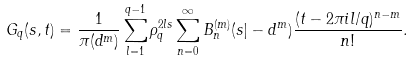<formula> <loc_0><loc_0><loc_500><loc_500>G _ { q } ( s , t ) = \frac { 1 } { \pi ( { d } ^ { m } ) } \sum _ { l = 1 } ^ { q - 1 } \rho _ { q } ^ { 2 l s } \sum _ { n = 0 } ^ { \infty } B _ { n } ^ { ( m ) } ( s | - { d } ^ { m } ) \frac { ( t - 2 \pi i l / q ) ^ { n - m } } { n ! } .</formula> 